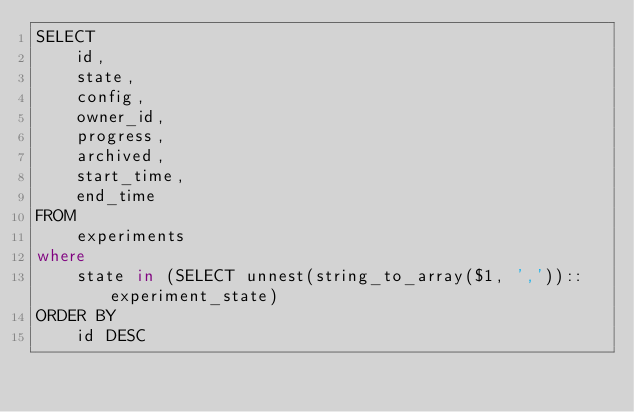Convert code to text. <code><loc_0><loc_0><loc_500><loc_500><_SQL_>SELECT
    id,
    state,
    config,
    owner_id,
    progress,
    archived,
    start_time,
    end_time
FROM
    experiments
where
    state in (SELECT unnest(string_to_array($1, ','))::experiment_state)
ORDER BY
    id DESC</code> 